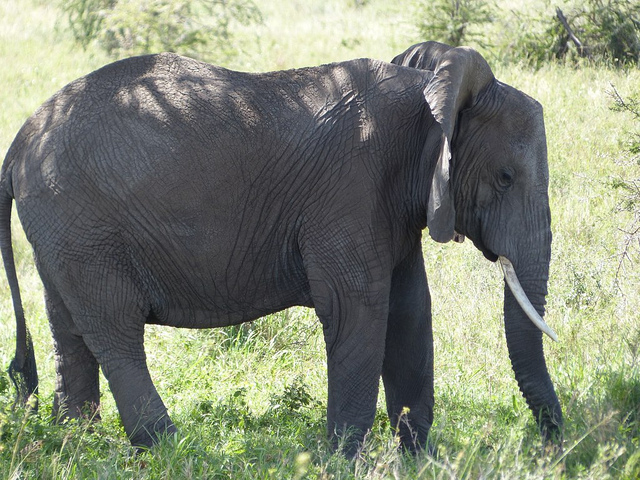<image>What color is the water the elephant is standing in? It is unknown what color the water is, as it is not clearly visible. What color is the water the elephant is standing in? I don't know what color is the water the elephant is standing in. There seems to be no water in the image. 